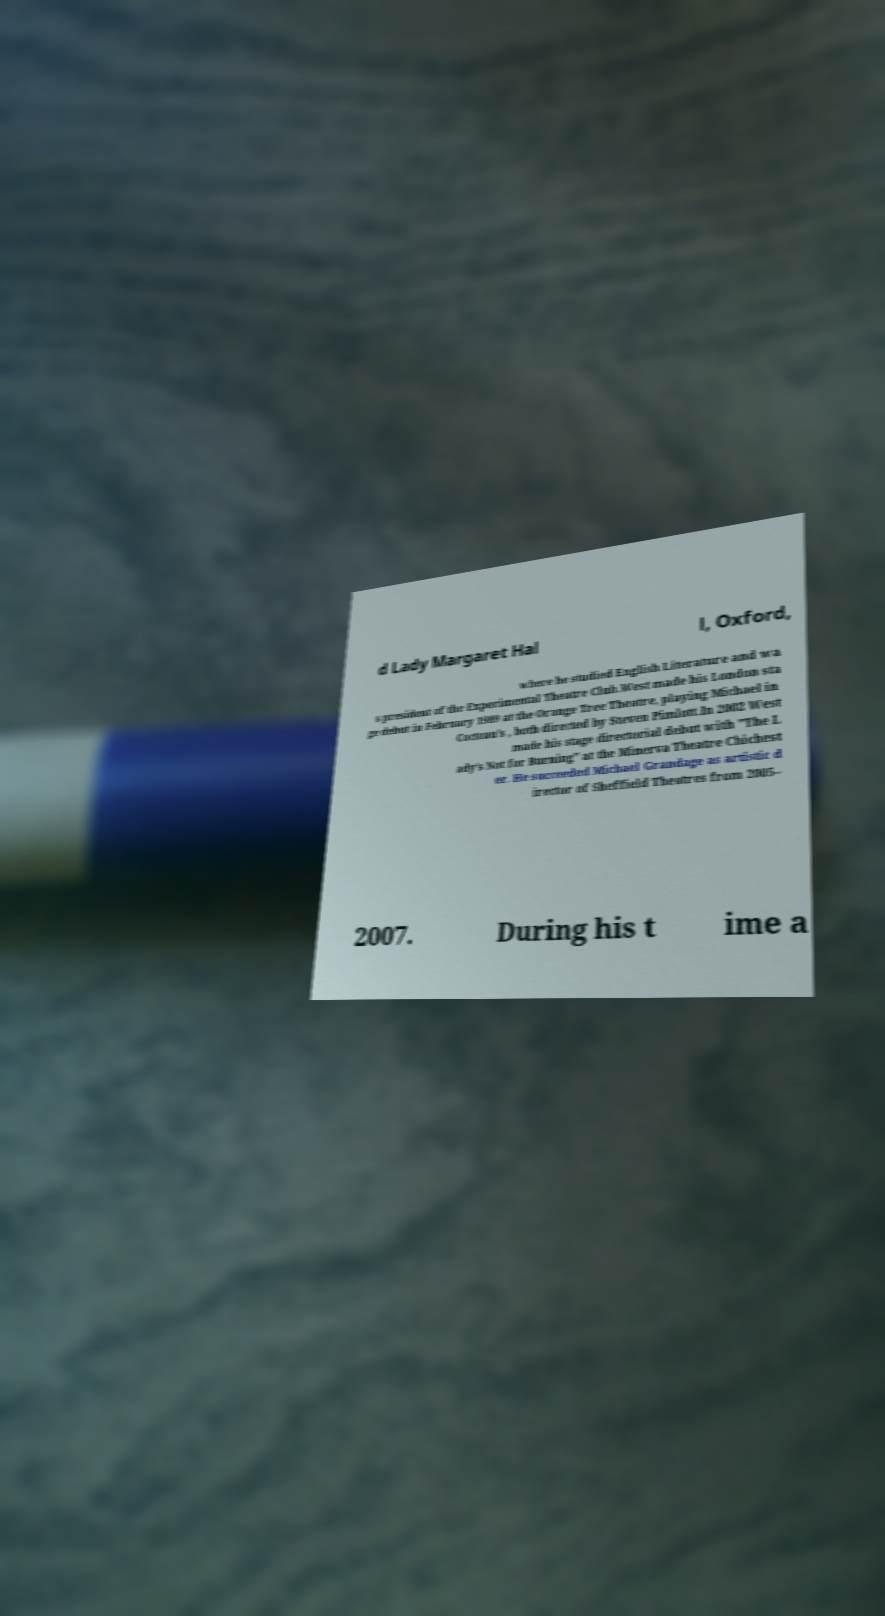Could you extract and type out the text from this image? d Lady Margaret Hal l, Oxford, where he studied English Literature and wa s president of the Experimental Theatre Club.West made his London sta ge debut in February 1989 at the Orange Tree Theatre, playing Michael in Cocteau's , both directed by Steven Pimlott.In 2002 West made his stage directorial debut with "The L ady's Not for Burning" at the Minerva Theatre Chichest er. He succeeded Michael Grandage as artistic d irector of Sheffield Theatres from 2005– 2007. During his t ime a 